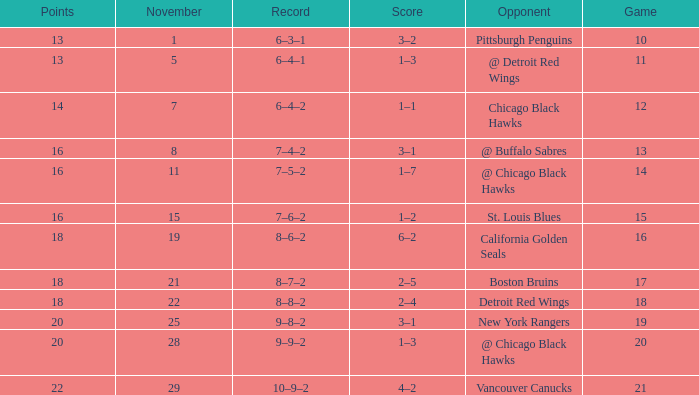What is the highest November that has a game less than 12, and @ detroit red wings as the opponent? 5.0. 